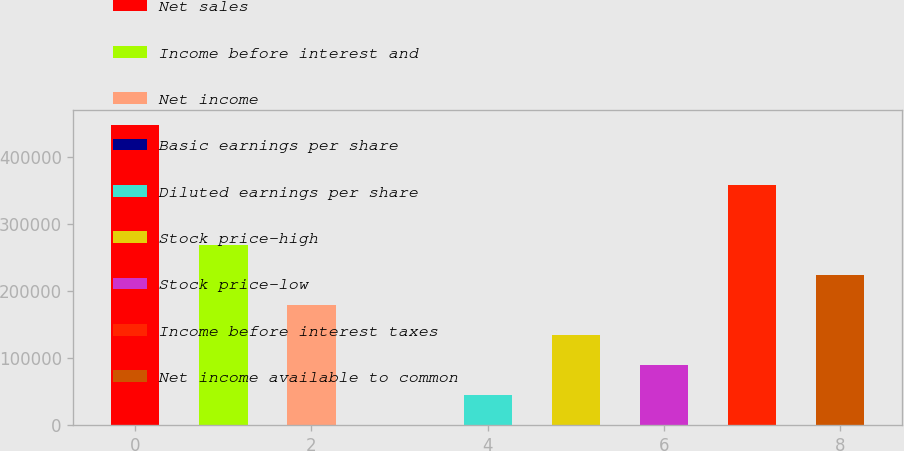<chart> <loc_0><loc_0><loc_500><loc_500><bar_chart><fcel>Net sales<fcel>Income before interest and<fcel>Net income<fcel>Basic earnings per share<fcel>Diluted earnings per share<fcel>Stock price-high<fcel>Stock price-low<fcel>Income before interest taxes<fcel>Net income available to common<nl><fcel>447390<fcel>268434<fcel>178956<fcel>0.11<fcel>44739.1<fcel>134217<fcel>89478.1<fcel>357912<fcel>223695<nl></chart> 